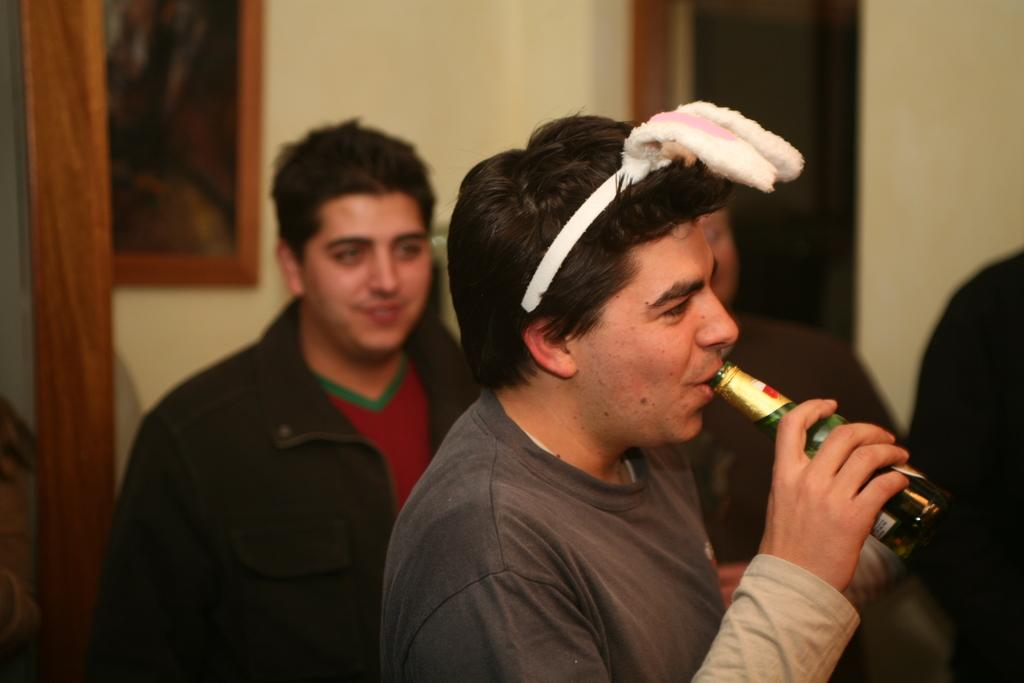Who is the main subject in the image? There is a man in the image. What is the man doing in the image? The man is standing in the image. What object is the man holding in his hand? The man is holding a wine bottle in his hand. Can you describe the background of the image? There are people standing in the background of the image. How does the man stop the wine bottle from falling in the image? The image does not show the man attempting to stop the wine bottle from falling, nor is there any indication that the wine bottle is falling. 